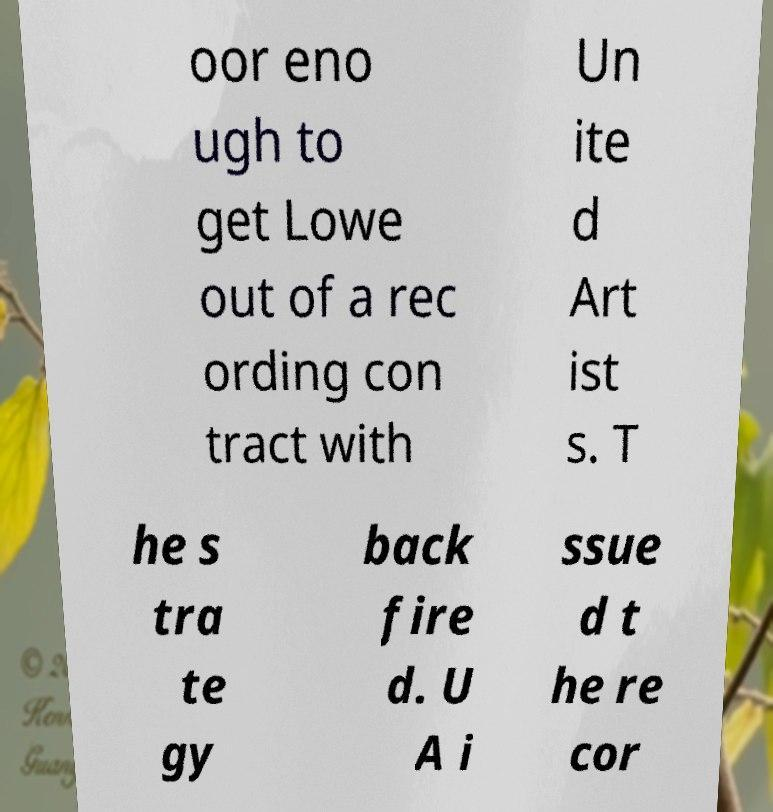I need the written content from this picture converted into text. Can you do that? oor eno ugh to get Lowe out of a rec ording con tract with Un ite d Art ist s. T he s tra te gy back fire d. U A i ssue d t he re cor 